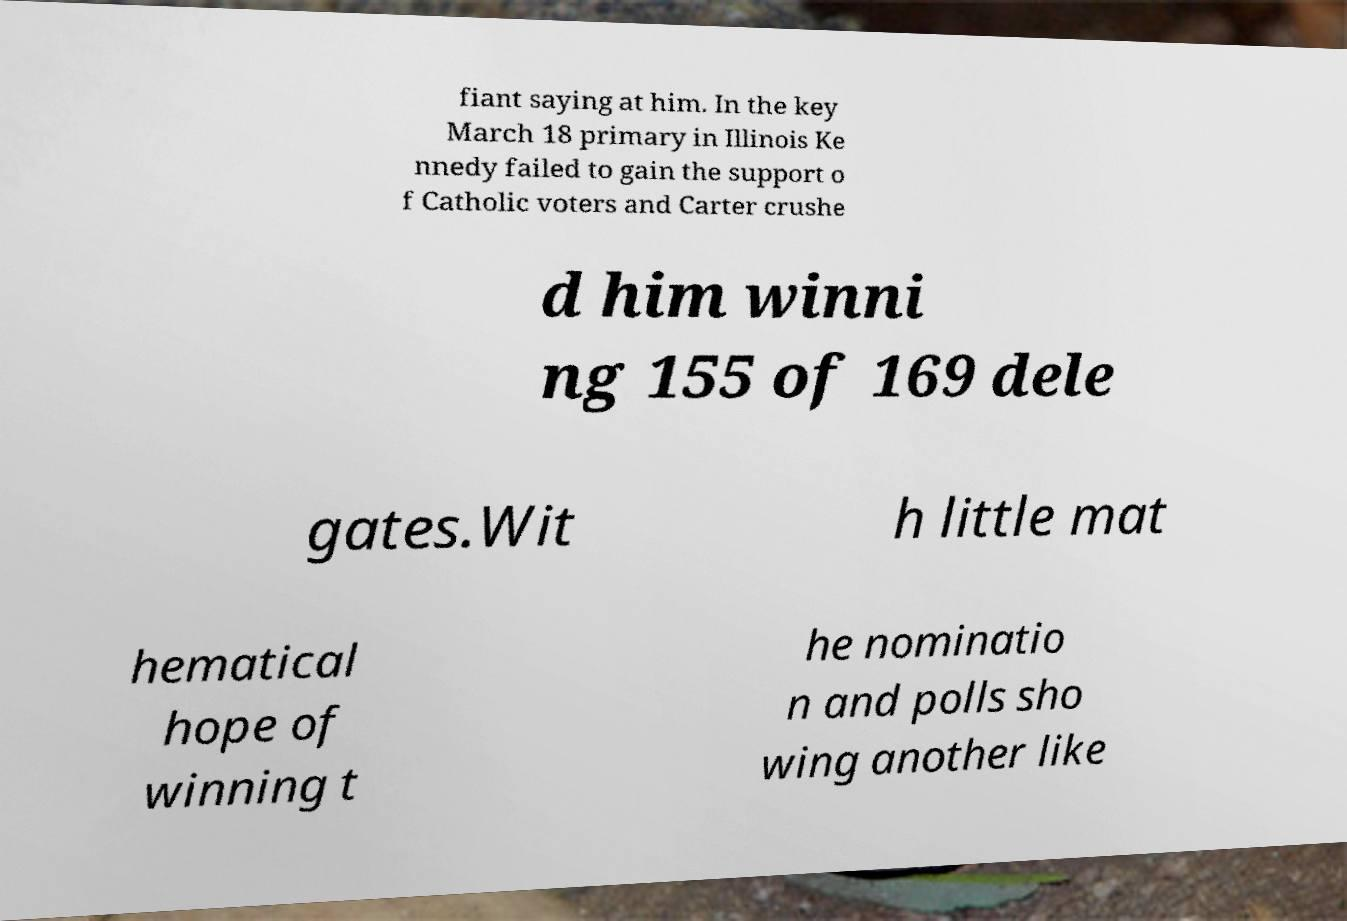What messages or text are displayed in this image? I need them in a readable, typed format. fiant saying at him. In the key March 18 primary in Illinois Ke nnedy failed to gain the support o f Catholic voters and Carter crushe d him winni ng 155 of 169 dele gates.Wit h little mat hematical hope of winning t he nominatio n and polls sho wing another like 